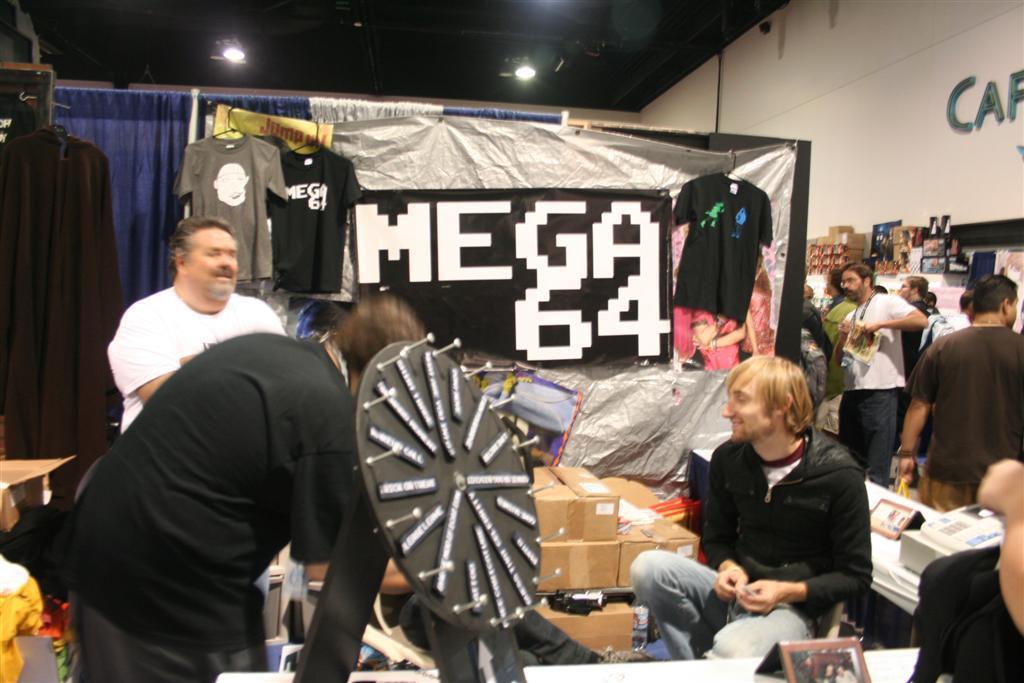In one or two sentences, can you explain what this image depicts? In this picture we can see a group of people, here we can see clothes, curtains, boxes and some objects and in the background we can see a wall, roof, lights. 